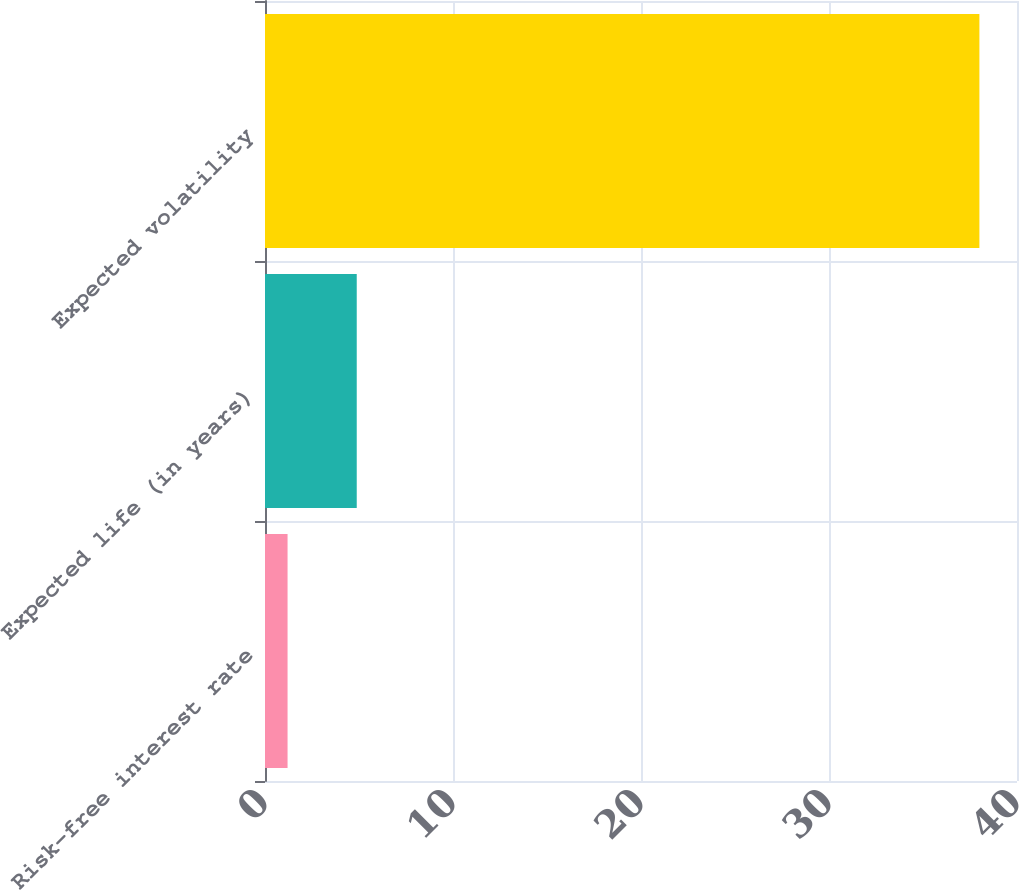Convert chart. <chart><loc_0><loc_0><loc_500><loc_500><bar_chart><fcel>Risk-free interest rate<fcel>Expected life (in years)<fcel>Expected volatility<nl><fcel>1.2<fcel>4.88<fcel>38<nl></chart> 